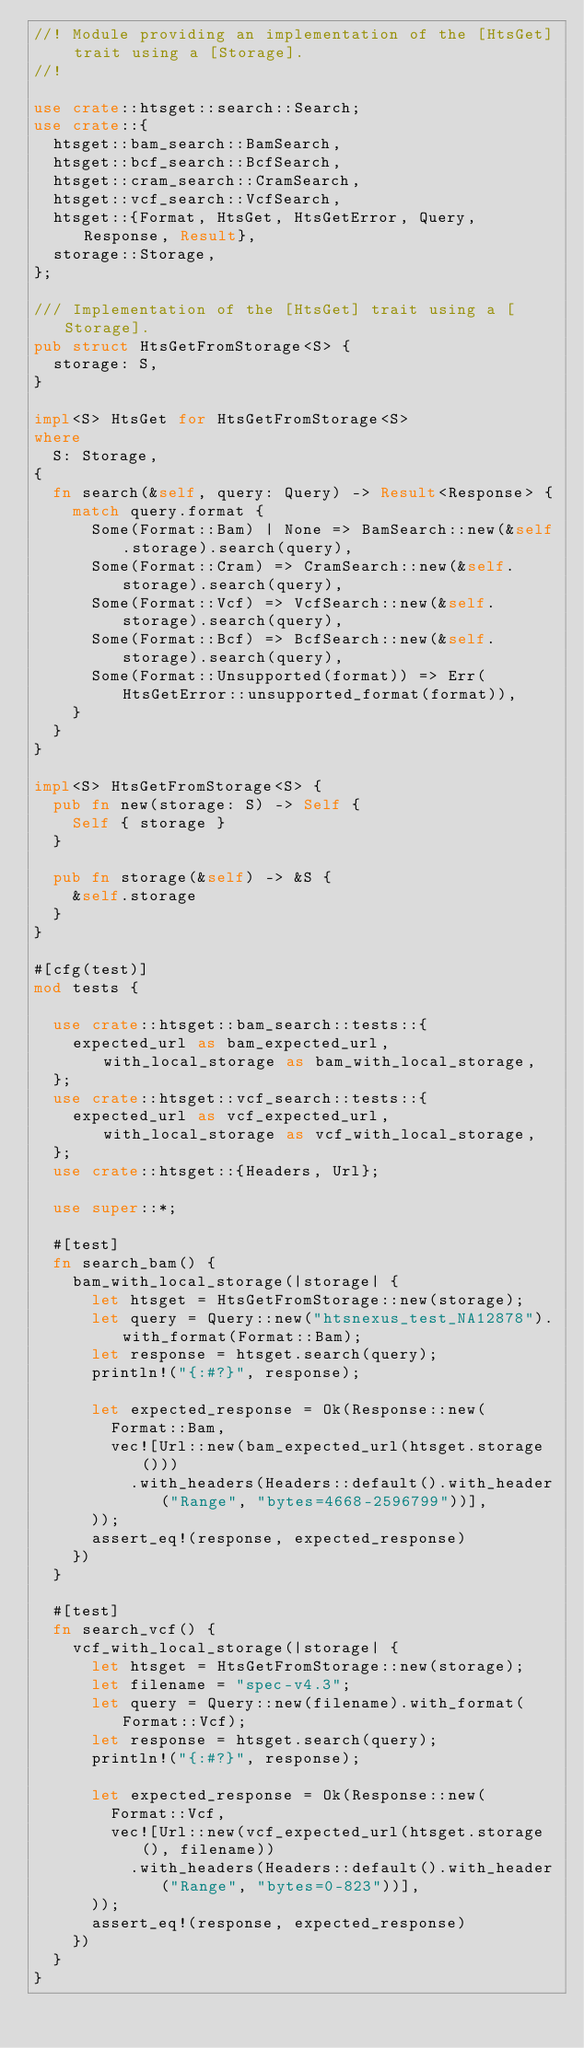Convert code to text. <code><loc_0><loc_0><loc_500><loc_500><_Rust_>//! Module providing an implementation of the [HtsGet] trait using a [Storage].
//!

use crate::htsget::search::Search;
use crate::{
  htsget::bam_search::BamSearch,
  htsget::bcf_search::BcfSearch,
  htsget::cram_search::CramSearch,
  htsget::vcf_search::VcfSearch,
  htsget::{Format, HtsGet, HtsGetError, Query, Response, Result},
  storage::Storage,
};

/// Implementation of the [HtsGet] trait using a [Storage].
pub struct HtsGetFromStorage<S> {
  storage: S,
}

impl<S> HtsGet for HtsGetFromStorage<S>
where
  S: Storage,
{
  fn search(&self, query: Query) -> Result<Response> {
    match query.format {
      Some(Format::Bam) | None => BamSearch::new(&self.storage).search(query),
      Some(Format::Cram) => CramSearch::new(&self.storage).search(query),
      Some(Format::Vcf) => VcfSearch::new(&self.storage).search(query),
      Some(Format::Bcf) => BcfSearch::new(&self.storage).search(query),
      Some(Format::Unsupported(format)) => Err(HtsGetError::unsupported_format(format)),
    }
  }
}

impl<S> HtsGetFromStorage<S> {
  pub fn new(storage: S) -> Self {
    Self { storage }
  }

  pub fn storage(&self) -> &S {
    &self.storage
  }
}

#[cfg(test)]
mod tests {

  use crate::htsget::bam_search::tests::{
    expected_url as bam_expected_url, with_local_storage as bam_with_local_storage,
  };
  use crate::htsget::vcf_search::tests::{
    expected_url as vcf_expected_url, with_local_storage as vcf_with_local_storage,
  };
  use crate::htsget::{Headers, Url};

  use super::*;

  #[test]
  fn search_bam() {
    bam_with_local_storage(|storage| {
      let htsget = HtsGetFromStorage::new(storage);
      let query = Query::new("htsnexus_test_NA12878").with_format(Format::Bam);
      let response = htsget.search(query);
      println!("{:#?}", response);

      let expected_response = Ok(Response::new(
        Format::Bam,
        vec![Url::new(bam_expected_url(htsget.storage()))
          .with_headers(Headers::default().with_header("Range", "bytes=4668-2596799"))],
      ));
      assert_eq!(response, expected_response)
    })
  }

  #[test]
  fn search_vcf() {
    vcf_with_local_storage(|storage| {
      let htsget = HtsGetFromStorage::new(storage);
      let filename = "spec-v4.3";
      let query = Query::new(filename).with_format(Format::Vcf);
      let response = htsget.search(query);
      println!("{:#?}", response);

      let expected_response = Ok(Response::new(
        Format::Vcf,
        vec![Url::new(vcf_expected_url(htsget.storage(), filename))
          .with_headers(Headers::default().with_header("Range", "bytes=0-823"))],
      ));
      assert_eq!(response, expected_response)
    })
  }
}
</code> 